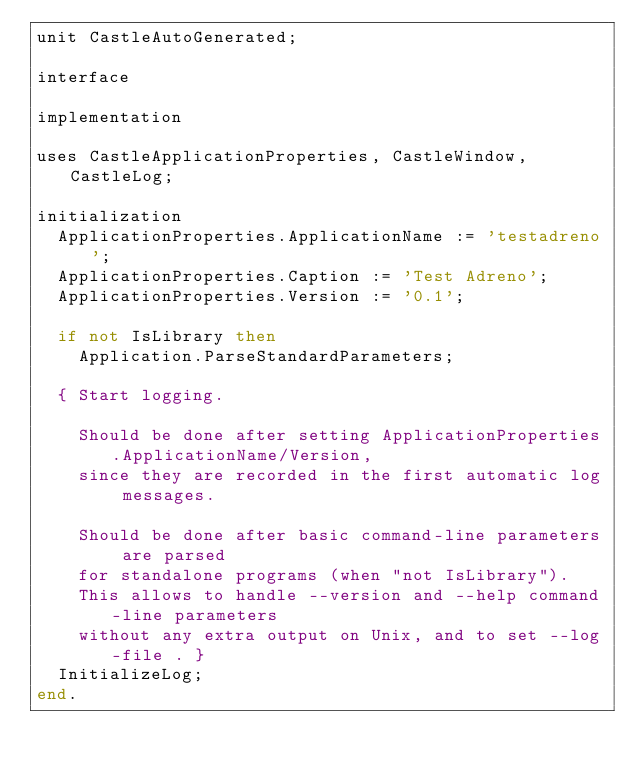Convert code to text. <code><loc_0><loc_0><loc_500><loc_500><_Pascal_>unit CastleAutoGenerated;

interface

implementation

uses CastleApplicationProperties, CastleWindow, CastleLog;

initialization
  ApplicationProperties.ApplicationName := 'testadreno';
  ApplicationProperties.Caption := 'Test Adreno';
  ApplicationProperties.Version := '0.1';

  if not IsLibrary then
    Application.ParseStandardParameters;

  { Start logging.

    Should be done after setting ApplicationProperties.ApplicationName/Version,
    since they are recorded in the first automatic log messages.

    Should be done after basic command-line parameters are parsed
    for standalone programs (when "not IsLibrary").
    This allows to handle --version and --help command-line parameters
    without any extra output on Unix, and to set --log-file . }
  InitializeLog;
end.
</code> 